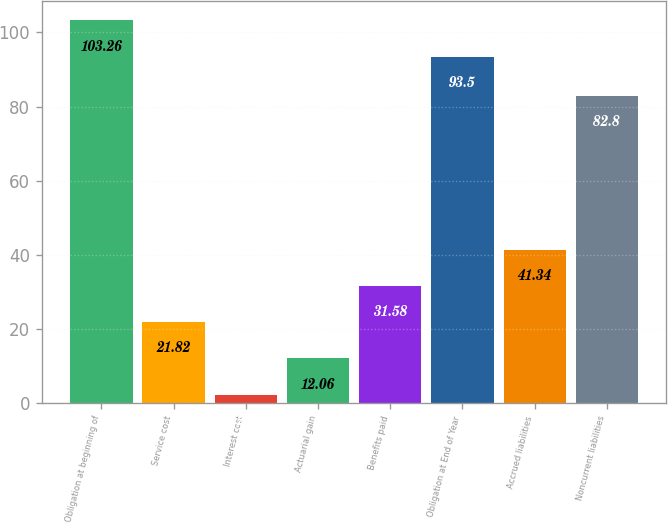<chart> <loc_0><loc_0><loc_500><loc_500><bar_chart><fcel>Obligation at beginning of<fcel>Service cost<fcel>Interest cost<fcel>Actuarial gain<fcel>Benefits paid<fcel>Obligation at End of Year<fcel>Accrued liabilities<fcel>Noncurrent liabilities<nl><fcel>103.26<fcel>21.82<fcel>2.3<fcel>12.06<fcel>31.58<fcel>93.5<fcel>41.34<fcel>82.8<nl></chart> 